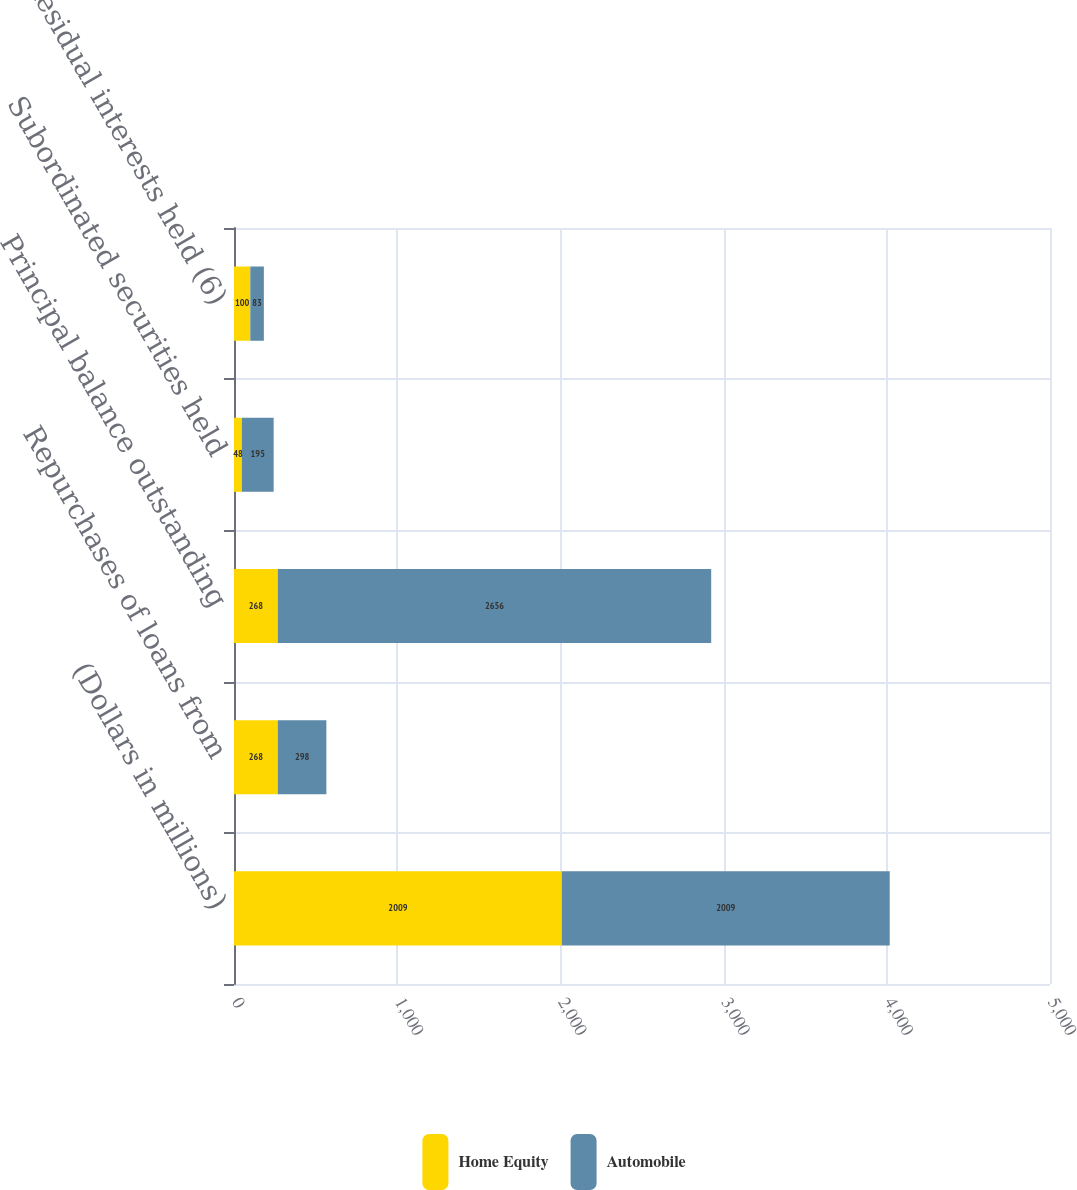<chart> <loc_0><loc_0><loc_500><loc_500><stacked_bar_chart><ecel><fcel>(Dollars in millions)<fcel>Repurchases of loans from<fcel>Principal balance outstanding<fcel>Subordinated securities held<fcel>Residual interests held (6)<nl><fcel>Home Equity<fcel>2009<fcel>268<fcel>268<fcel>48<fcel>100<nl><fcel>Automobile<fcel>2009<fcel>298<fcel>2656<fcel>195<fcel>83<nl></chart> 